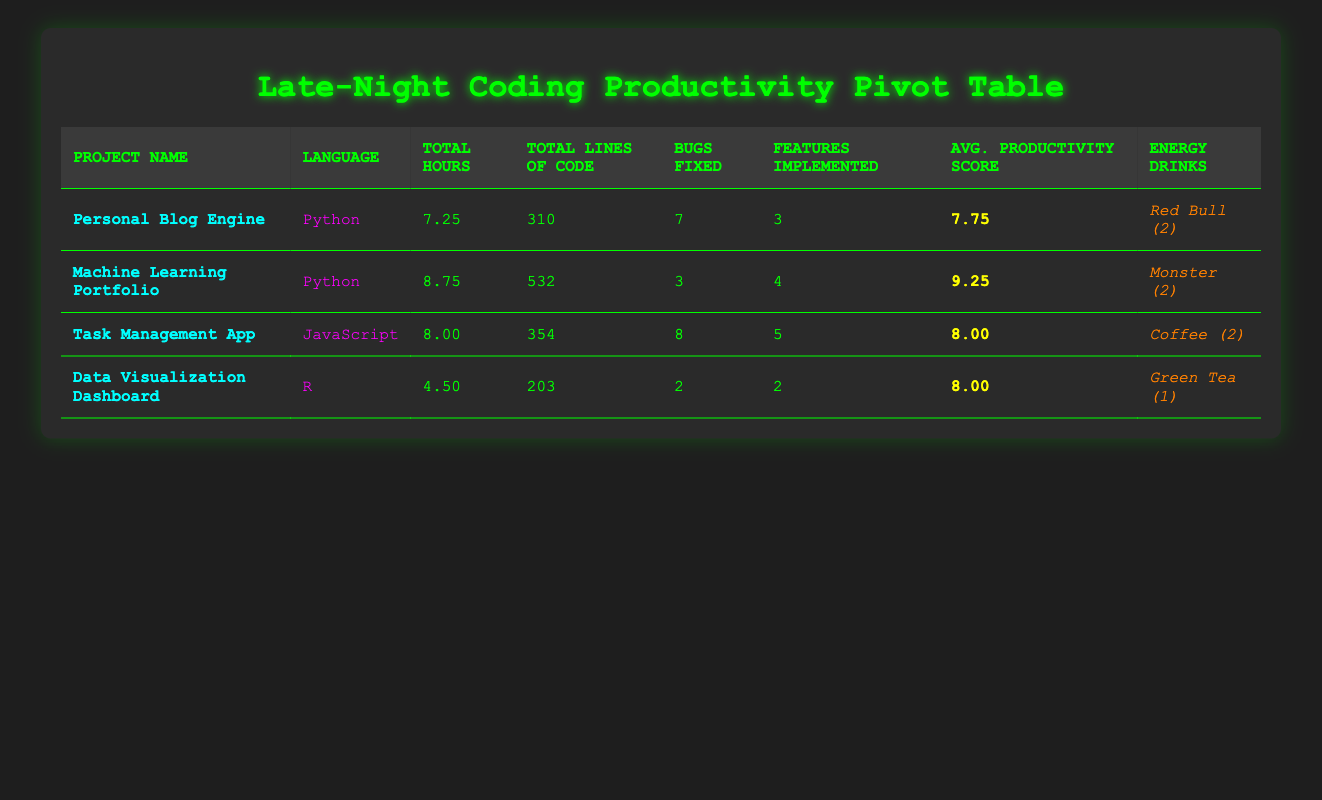What is the total number of bugs fixed in the "Task Management App"? According to the table, the "Task Management App" has fixed a total of 8 bugs across two entries (5 bugs on May 3rd and 3 bugs on May 7th). Adding these together gives a total of 8.
Answer: 8 Which project had the highest average productivity score? From the table, the average productivity scores for each project are: Personal Blog Engine (7.75), Machine Learning Portfolio (9.25), Task Management App (8.00), and Data Visualization Dashboard (8.00). The highest score is 9.25 for the Machine Learning Portfolio.
Answer: Machine Learning Portfolio How many lines of code were written in total for the "Personal Blog Engine"? The total lines of code for the "Personal Blog Engine" are the sum of lines written in both sessions: 178 (on May 1st) and 132 (on May 5th), which totals to 310.
Answer: 310 What is the average number of features implemented across all projects? To find the average, add the total number of features implemented: 3 (Blog Engine) + 4 (ML Portfolio) + 5 (Task Management App) + 2 (Data Visualization Dashboard) = 14 features. There are a total of 4 projects, so the average is 14 / 4 = 3.5.
Answer: 3.5 Was there any day when more than two features were implemented? Examining the table, the "Task Management App" had 3 features implemented (on May 3rd) and the "Machine Learning Portfolio" had 3 features implemented (on May 6th). Therefore, there were days when more than two features were implemented.
Answer: Yes Which programming language was associated with the least total hours of late-night coding? The total hours for each language are as follows: Python (16.00), JavaScript (8.00), and R (4.50). The language associated with the least total hours is R at 4.50 hours.
Answer: R On which date was the "Machine Learning Portfolio" worked on for the longest period? The "Machine Learning Portfolio" was worked on for the periods of 4.5 hours (May 2nd) and 8.75 hours (May 6th). Clearly, the longest period is on May 6th, which is 8.75 hours.
Answer: May 6th What energy drink was consumed the most? The energy drinks consumed were Red Bull (2), Monster (2), Coffee (2), and Green Tea (1). Since Red Bull, Monster, and Coffee were each consumed twice, there is a tie for the most consumed.
Answer: Red Bull, Monster, Coffee What is the total number of lines of code written in projects written in Python? The total lines of code in Python projects are: 178 (Blog Engine, May 1st) + 245 (Machine Learning Portfolio, May 2nd) + 132 (Blog Engine, May 5th) + 287 (Machine Learning Portfolio, May 6th) = 842 lines.
Answer: 842 